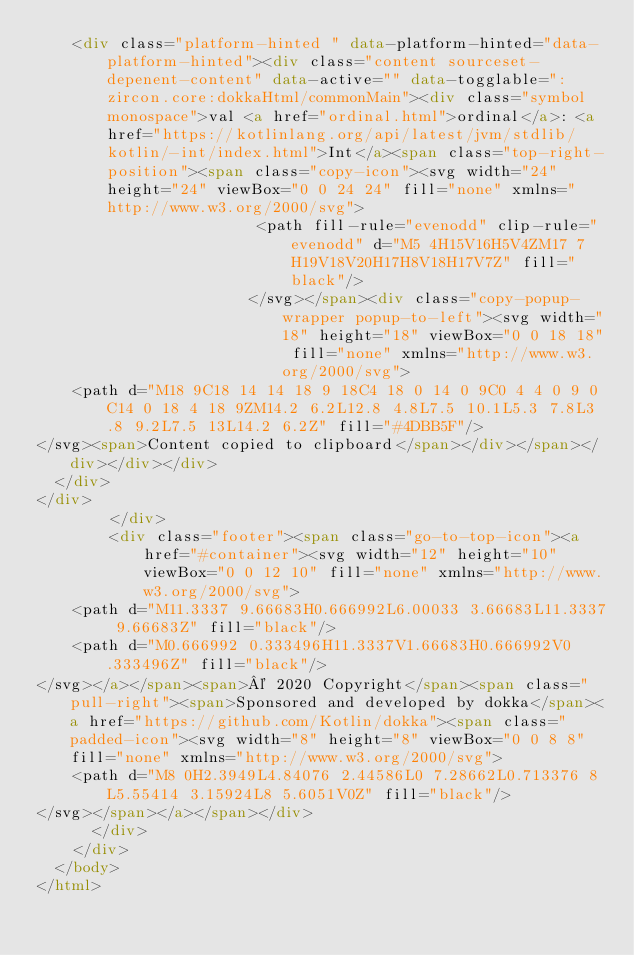Convert code to text. <code><loc_0><loc_0><loc_500><loc_500><_HTML_>    <div class="platform-hinted " data-platform-hinted="data-platform-hinted"><div class="content sourceset-depenent-content" data-active="" data-togglable=":zircon.core:dokkaHtml/commonMain"><div class="symbol monospace">val <a href="ordinal.html">ordinal</a>: <a href="https://kotlinlang.org/api/latest/jvm/stdlib/kotlin/-int/index.html">Int</a><span class="top-right-position"><span class="copy-icon"><svg width="24" height="24" viewBox="0 0 24 24" fill="none" xmlns="http://www.w3.org/2000/svg">
                        <path fill-rule="evenodd" clip-rule="evenodd" d="M5 4H15V16H5V4ZM17 7H19V18V20H17H8V18H17V7Z" fill="black"/>
                       </svg></span><div class="copy-popup-wrapper popup-to-left"><svg width="18" height="18" viewBox="0 0 18 18" fill="none" xmlns="http://www.w3.org/2000/svg">
    <path d="M18 9C18 14 14 18 9 18C4 18 0 14 0 9C0 4 4 0 9 0C14 0 18 4 18 9ZM14.2 6.2L12.8 4.8L7.5 10.1L5.3 7.8L3.8 9.2L7.5 13L14.2 6.2Z" fill="#4DBB5F"/>
</svg><span>Content copied to clipboard</span></div></span></div></div></div>
  </div>
</div>
        </div>
        <div class="footer"><span class="go-to-top-icon"><a href="#container"><svg width="12" height="10" viewBox="0 0 12 10" fill="none" xmlns="http://www.w3.org/2000/svg">
    <path d="M11.3337 9.66683H0.666992L6.00033 3.66683L11.3337 9.66683Z" fill="black"/>
    <path d="M0.666992 0.333496H11.3337V1.66683H0.666992V0.333496Z" fill="black"/>
</svg></a></span><span>© 2020 Copyright</span><span class="pull-right"><span>Sponsored and developed by dokka</span><a href="https://github.com/Kotlin/dokka"><span class="padded-icon"><svg width="8" height="8" viewBox="0 0 8 8" fill="none" xmlns="http://www.w3.org/2000/svg">
    <path d="M8 0H2.3949L4.84076 2.44586L0 7.28662L0.713376 8L5.55414 3.15924L8 5.6051V0Z" fill="black"/>
</svg></span></a></span></div>
      </div>
    </div>
  </body>
</html>

</code> 